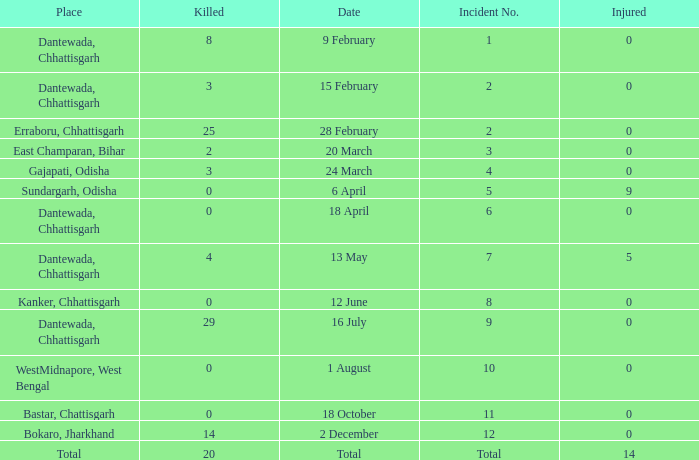What is the least amount of injuries in Dantewada, Chhattisgarh when 8 people were killed? 0.0. 